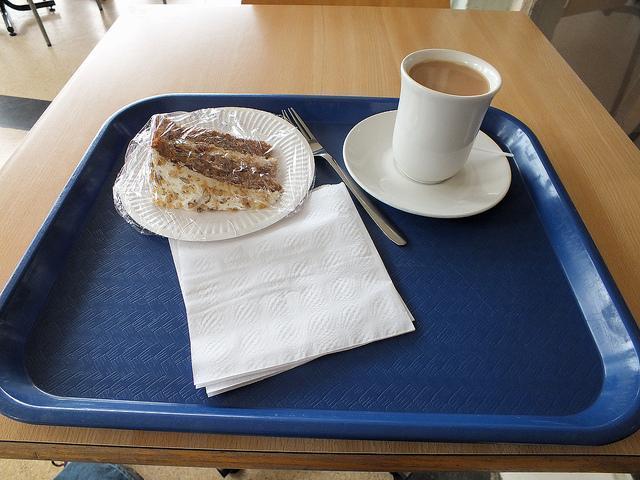How many pieces of silverware is on the tray?
Give a very brief answer. 1. How many giraffes are there?
Give a very brief answer. 0. 